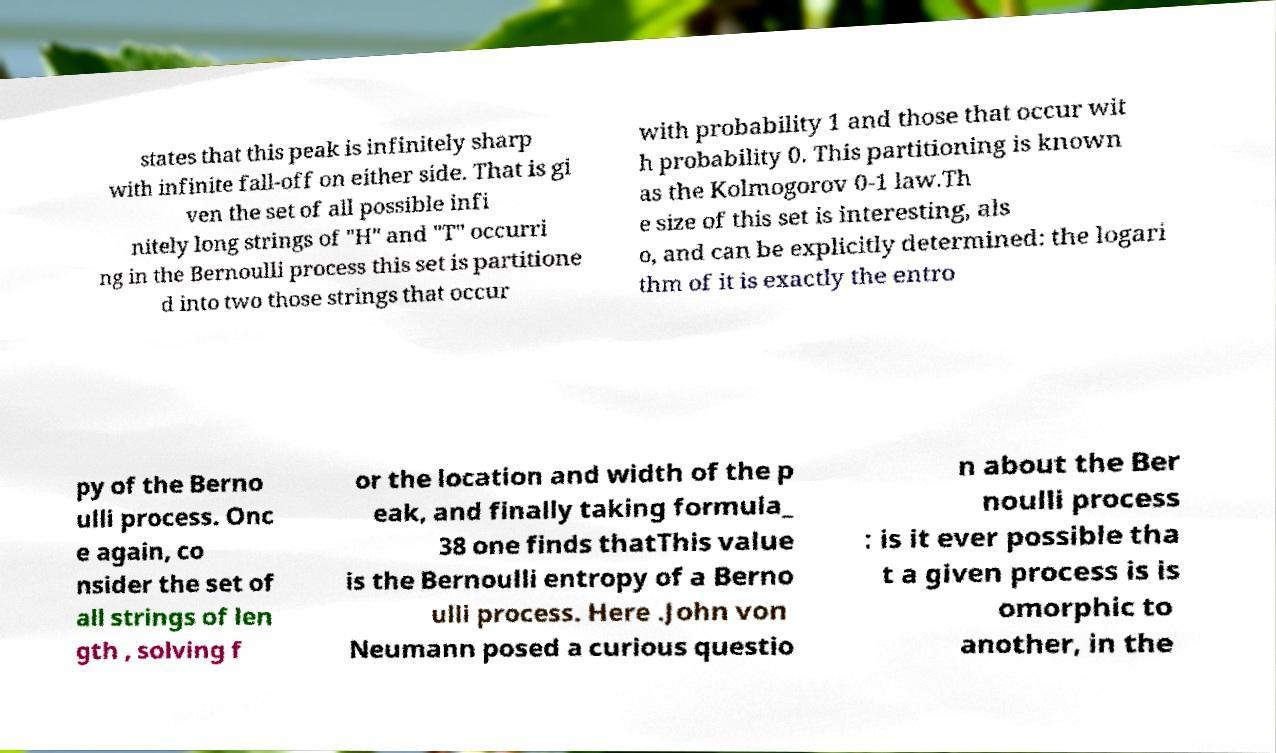What messages or text are displayed in this image? I need them in a readable, typed format. states that this peak is infinitely sharp with infinite fall-off on either side. That is gi ven the set of all possible infi nitely long strings of "H" and "T" occurri ng in the Bernoulli process this set is partitione d into two those strings that occur with probability 1 and those that occur wit h probability 0. This partitioning is known as the Kolmogorov 0-1 law.Th e size of this set is interesting, als o, and can be explicitly determined: the logari thm of it is exactly the entro py of the Berno ulli process. Onc e again, co nsider the set of all strings of len gth , solving f or the location and width of the p eak, and finally taking formula_ 38 one finds thatThis value is the Bernoulli entropy of a Berno ulli process. Here .John von Neumann posed a curious questio n about the Ber noulli process : is it ever possible tha t a given process is is omorphic to another, in the 